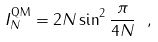Convert formula to latex. <formula><loc_0><loc_0><loc_500><loc_500>I _ { N } ^ { \text {QM} } = 2 N \sin ^ { 2 } \frac { \pi } { 4 N } \ ,</formula> 